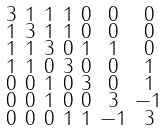<formula> <loc_0><loc_0><loc_500><loc_500>\begin{smallmatrix} 3 & 1 & 1 & 1 & 0 & 0 & 0 \\ 1 & 3 & 1 & 1 & 0 & 0 & 0 \\ 1 & 1 & 3 & 0 & 1 & 1 & 0 \\ 1 & 1 & 0 & 3 & 0 & 0 & 1 \\ 0 & 0 & 1 & 0 & 3 & 0 & 1 \\ 0 & 0 & 1 & 0 & 0 & 3 & - 1 \\ 0 & 0 & 0 & 1 & 1 & - 1 & 3 \end{smallmatrix}</formula> 